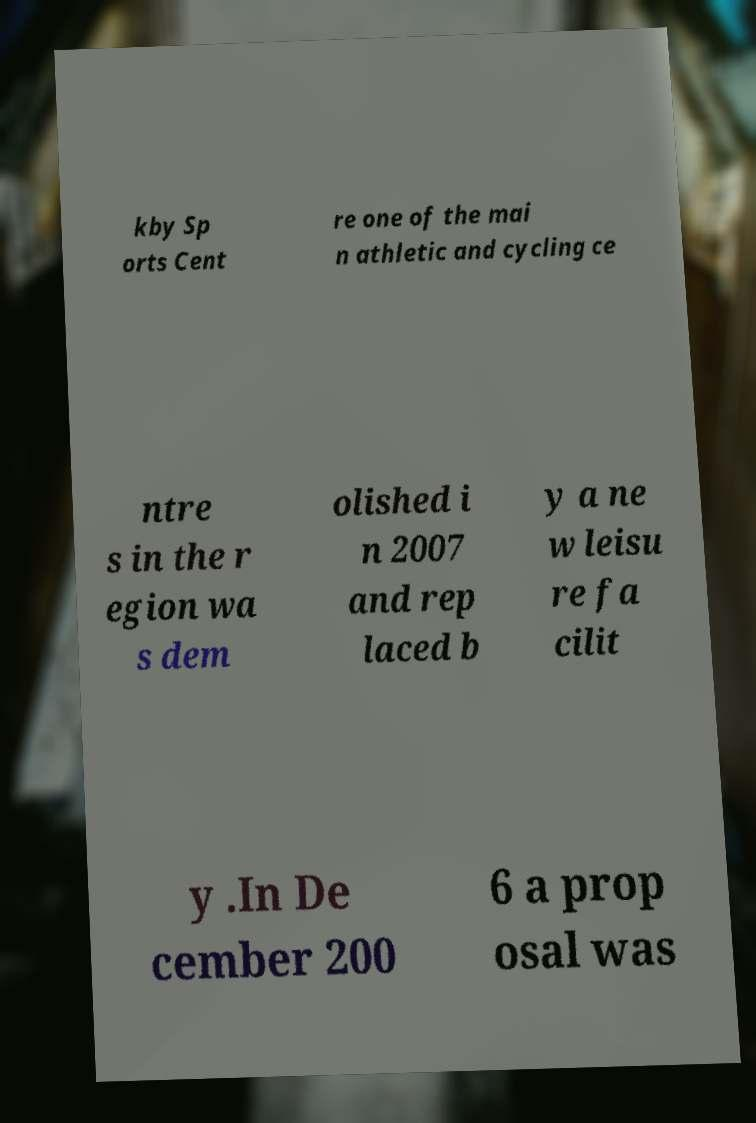For documentation purposes, I need the text within this image transcribed. Could you provide that? kby Sp orts Cent re one of the mai n athletic and cycling ce ntre s in the r egion wa s dem olished i n 2007 and rep laced b y a ne w leisu re fa cilit y .In De cember 200 6 a prop osal was 